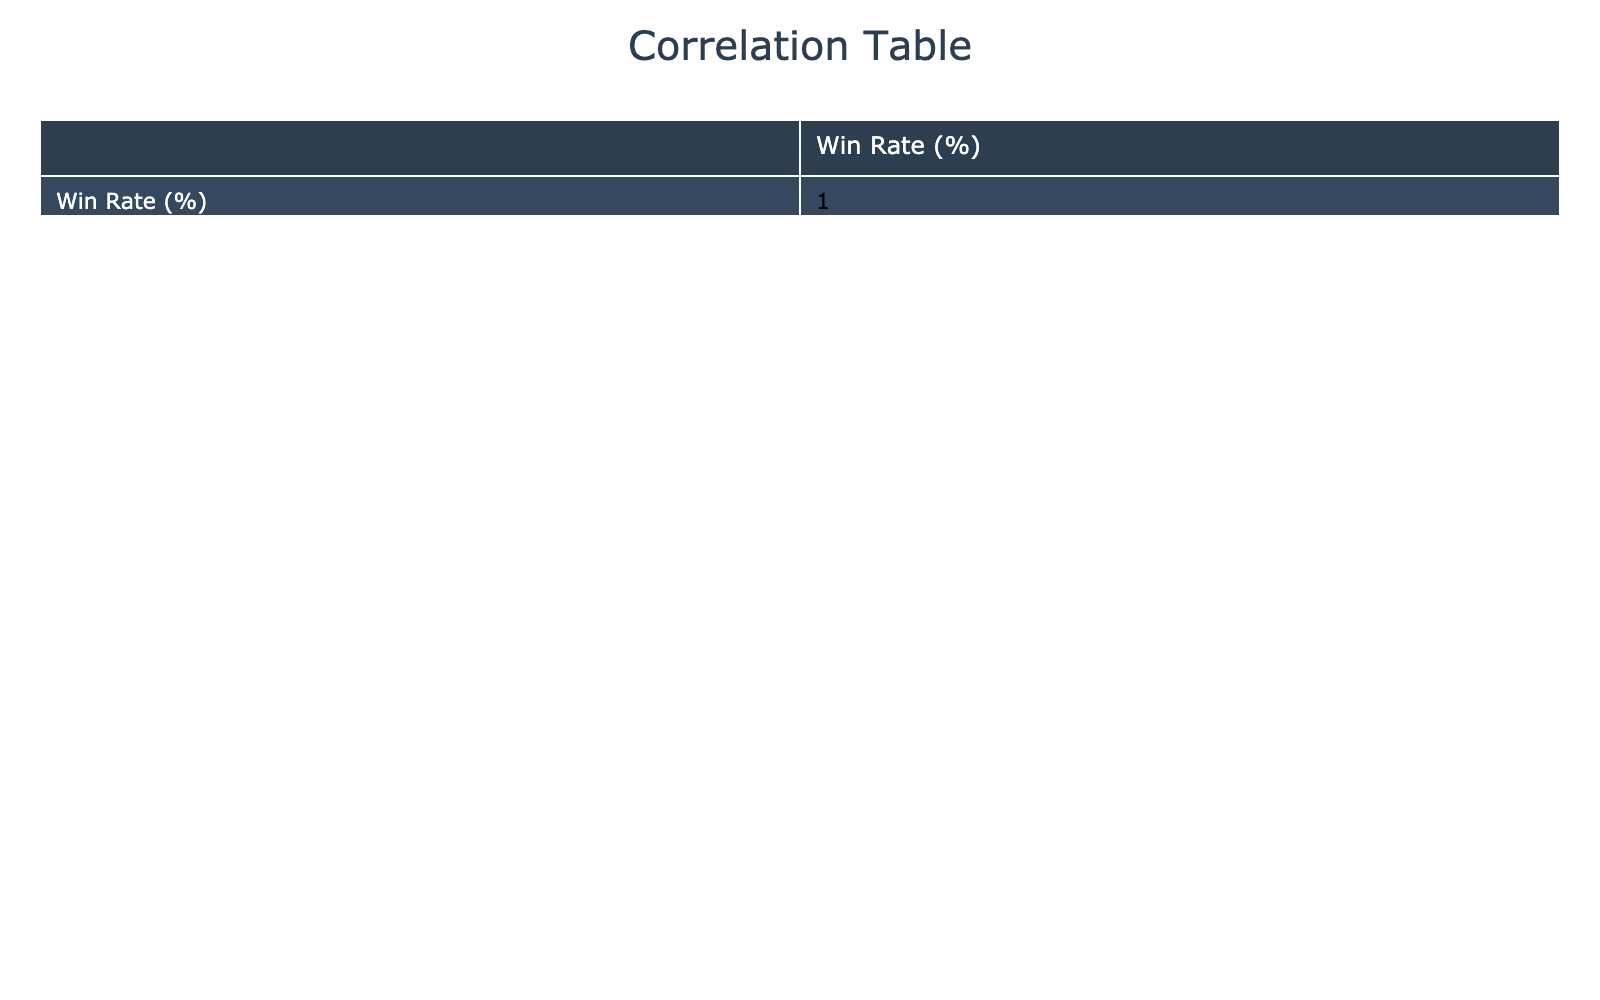What is the win rate for Tennis? From the table, the win rate for Tennis is directly listed under the "Win Rate (%)" column. The entry for Tennis shows a win rate of 55%.
Answer: 55 Which sport has the highest win rate? By examining the "Win Rate (%)" column, we find that Swimming has the highest win rate at 75%. This is the maximum value in the column.
Answer: 75 What is the average win rate of sports with a high psychological focus? First, we identify the sports marked with a "High" psychological focus: Soccer, Tennis, Rugby, Field Hockey, and Volleyball. Their win rates are 65%, 55%, 68%, 62%, and 64%. Adding them gives 65 + 55 + 68 + 62 + 64 = 314, and dividing by 5 (number of sports) results in an average of 314 / 5 = 62.8%.
Answer: 62.8 Is there a correlation between physical conditioning and win rate? To determine this, we need to refer to the correlation table. By observing the correlation values, we find a positive correlation between Physical Conditioning and Win Rate which indicates that as physical conditioning increases, win rates also tend to increase.
Answer: Yes Which sport has the lowest win rate and what is it? Looking through the "Win Rate (%)" column, we see that Cricket has the lowest win rate listed at 50%. This is the minimum value in that column.
Answer: 50 What difference in win rates do you see between Fast-paced transition strategy and Defensive strategy? Fast-paced transition strategy (Basketball) has a win rate of 70%, while the Defensive strategy (American Football) has a win rate of 60%. The difference between them is 70 - 60 = 10%.
Answer: 10% What percentage of sports with moderate physical conditioning have a win rate above 60%? The sports with moderate physical conditioning are Soccer, Field Hockey, and Baseball. Out of these, Soccer and Field Hockey have win rates over 60% (65% and 62%). So there are 2 out of 3 sports, which is (2/3) * 100 = 66.67%.
Answer: 66.67% Does a possession-based strategy correlate with higher psychological focus? Checking the correlation value between "Game Strategy Preference" (Possession-based for Soccer) and "Psychological Focus", we see Soccer has a high psychological focus. Since it's only one data point, it can suggest some correlation, but further analysis of other strategies would be required for a strong conclusion.
Answer: Yes, but needs more data for strong conclusion 